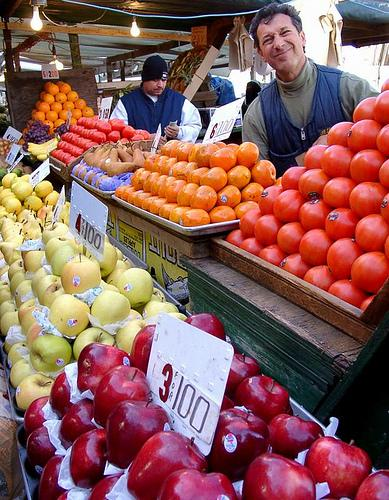What is the name of the red apples? Please explain your reasoning. red delicious. The red apples are called red delicious apples given their color. 